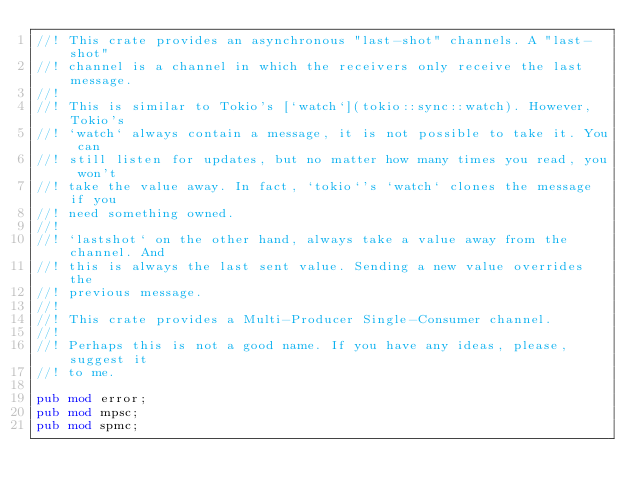<code> <loc_0><loc_0><loc_500><loc_500><_Rust_>//! This crate provides an asynchronous "last-shot" channels. A "last-shot"
//! channel is a channel in which the receivers only receive the last message.
//!
//! This is similar to Tokio's [`watch`](tokio::sync::watch). However, Tokio's
//! `watch` always contain a message, it is not possible to take it. You can
//! still listen for updates, but no matter how many times you read, you won't
//! take the value away. In fact, `tokio`'s `watch` clones the message if you
//! need something owned.
//!
//! `lastshot` on the other hand, always take a value away from the channel. And
//! this is always the last sent value. Sending a new value overrides the
//! previous message.
//!
//! This crate provides a Multi-Producer Single-Consumer channel.
//!
//! Perhaps this is not a good name. If you have any ideas, please, suggest it
//! to me.

pub mod error;
pub mod mpsc;
pub mod spmc;
</code> 